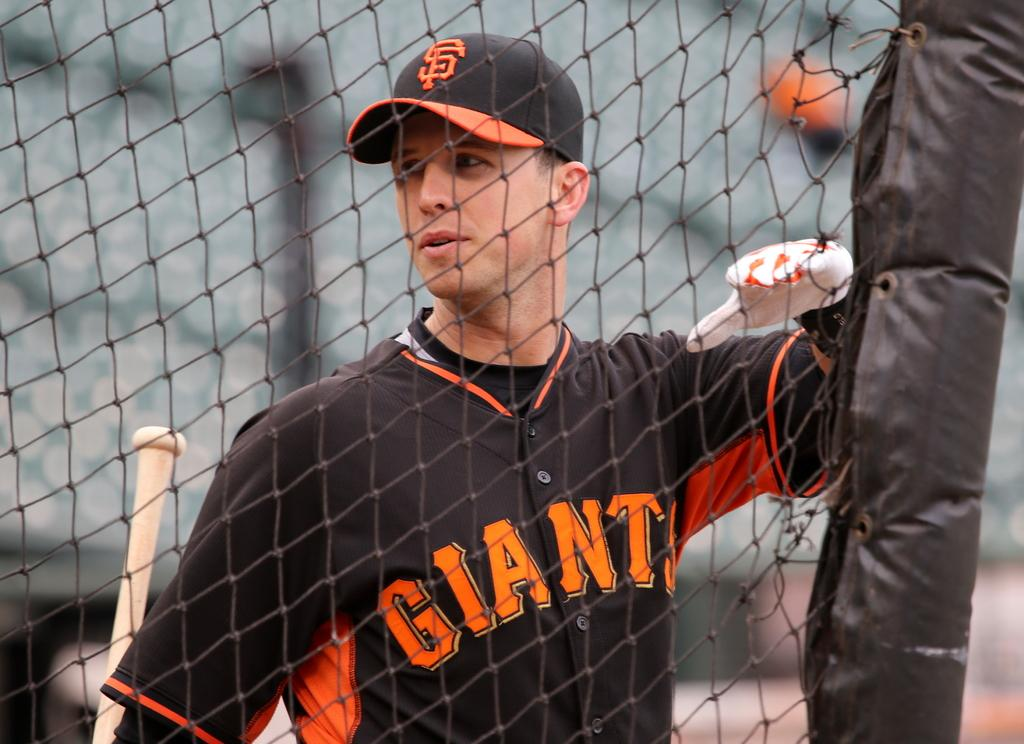Provide a one-sentence caption for the provided image. Baseball player standing in front of a fence with a giant jersey. 